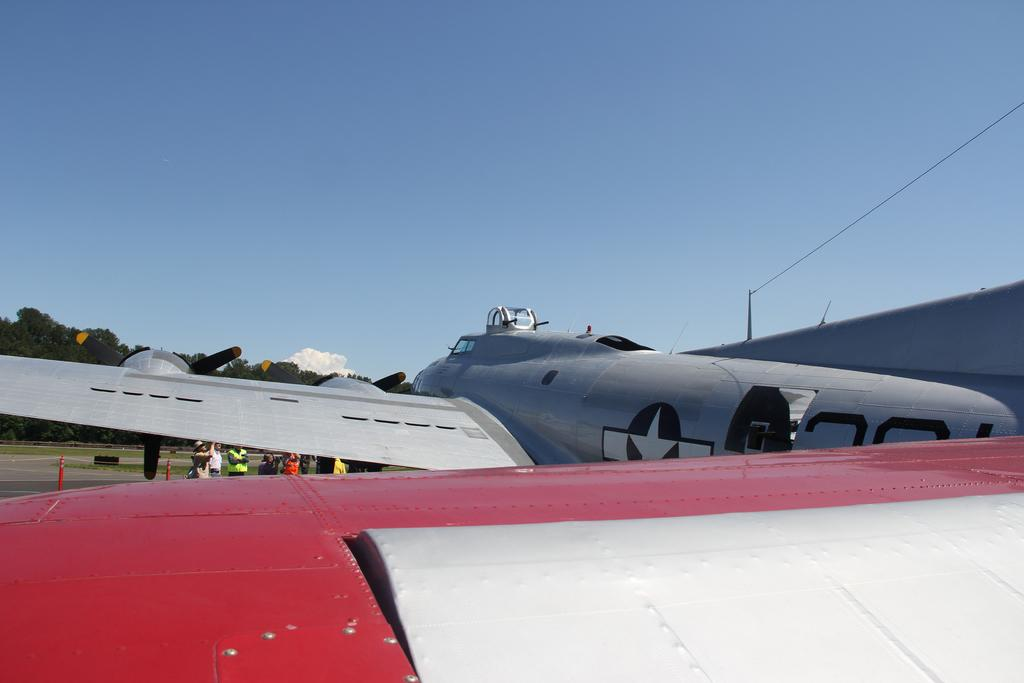What is the main subject in the foreground of the image? There is an aircraft in the foreground of the image. What else can be seen in the foreground of the image? There is a cable in the foreground of the image. What is visible in the background of the image? There are people, trees, and the sky visible in the background of the image. What type of shop can be seen in the image? There is no shop present in the image. What decision is the aircraft making in the image? Aircrafts do not make decisions; they are inanimate objects. 